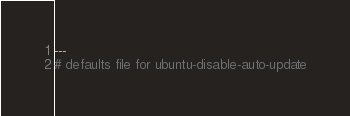Convert code to text. <code><loc_0><loc_0><loc_500><loc_500><_YAML_>---
# defaults file for ubuntu-disable-auto-update</code> 